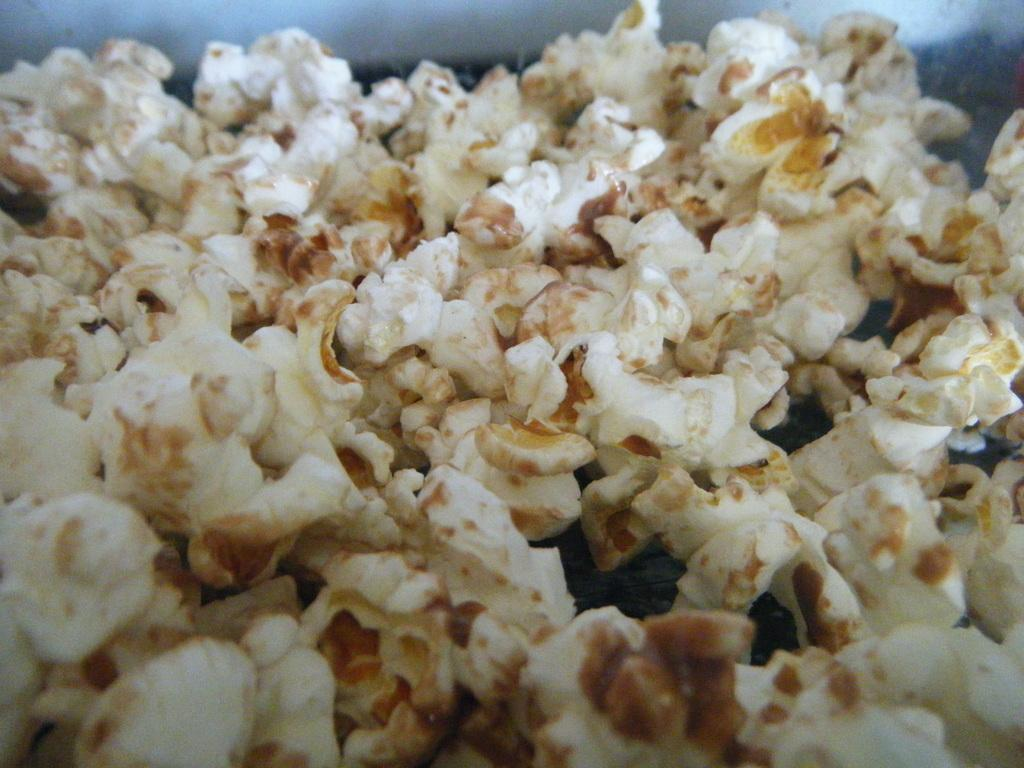What type of food is present in the image? There is popcorn in the image. How many men are depicted stamping waste in the image? There are no men, stamping, or waste present in the image; it only features popcorn. 